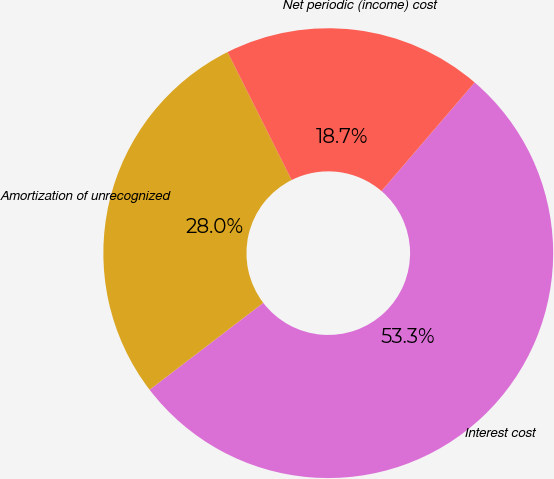Convert chart. <chart><loc_0><loc_0><loc_500><loc_500><pie_chart><fcel>Interest cost<fcel>Amortization of unrecognized<fcel>Net periodic (income) cost<nl><fcel>53.33%<fcel>28.0%<fcel>18.67%<nl></chart> 